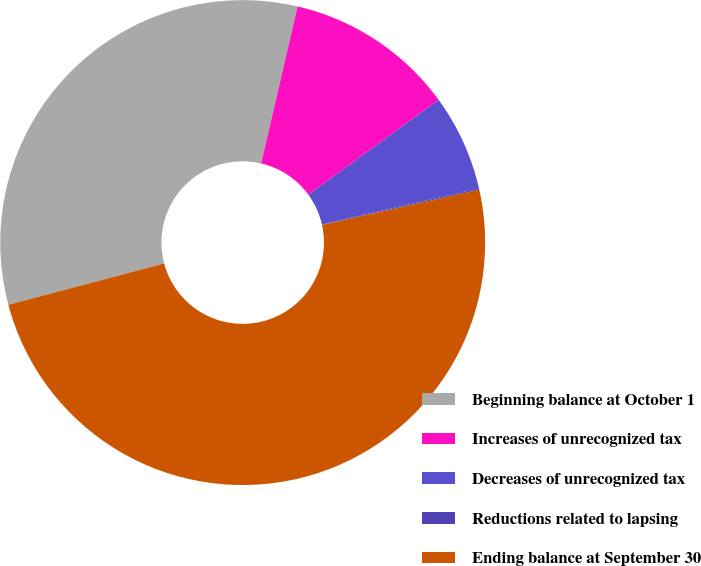<chart> <loc_0><loc_0><loc_500><loc_500><pie_chart><fcel>Beginning balance at October 1<fcel>Increases of unrecognized tax<fcel>Decreases of unrecognized tax<fcel>Reductions related to lapsing<fcel>Ending balance at September 30<nl><fcel>32.77%<fcel>11.35%<fcel>6.42%<fcel>0.1%<fcel>49.37%<nl></chart> 